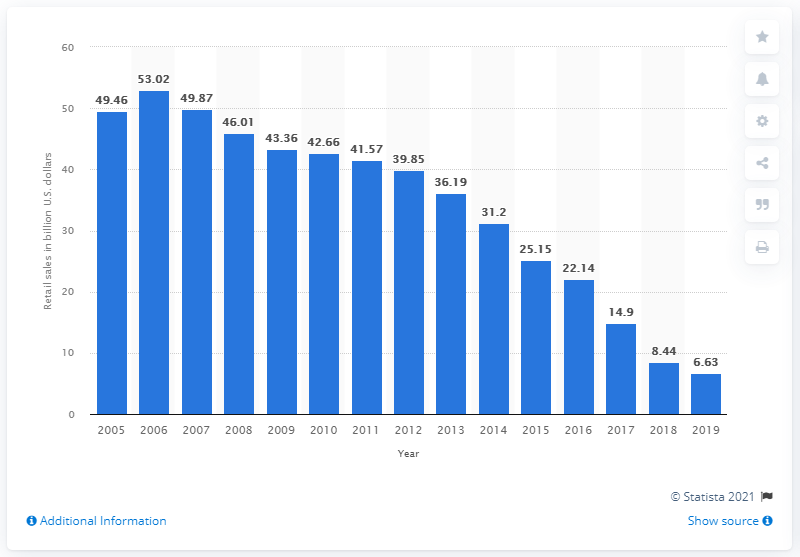Indicate a few pertinent items in this graphic. In 2006, the revenue of Sears Holdings was 53.02. In 2019, Sears Holdings' global retail sales amounted to approximately 6.63 billion US dollars. 